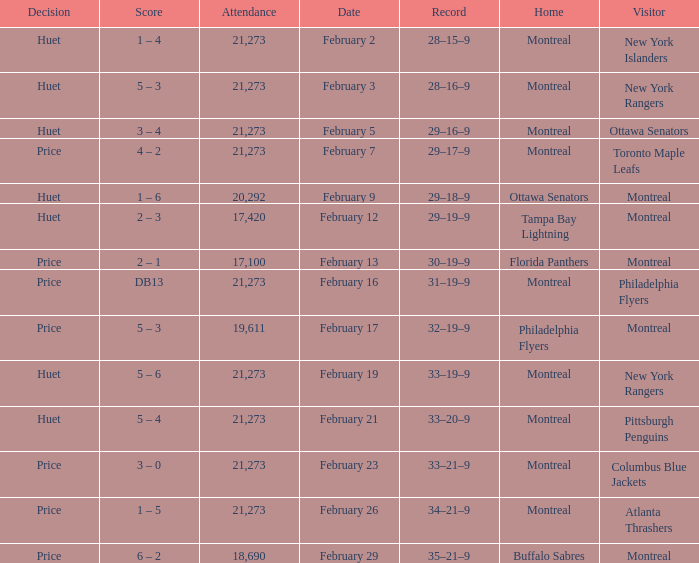Who was the visiting team at the game when the Canadiens had a record of 30–19–9? Montreal. 